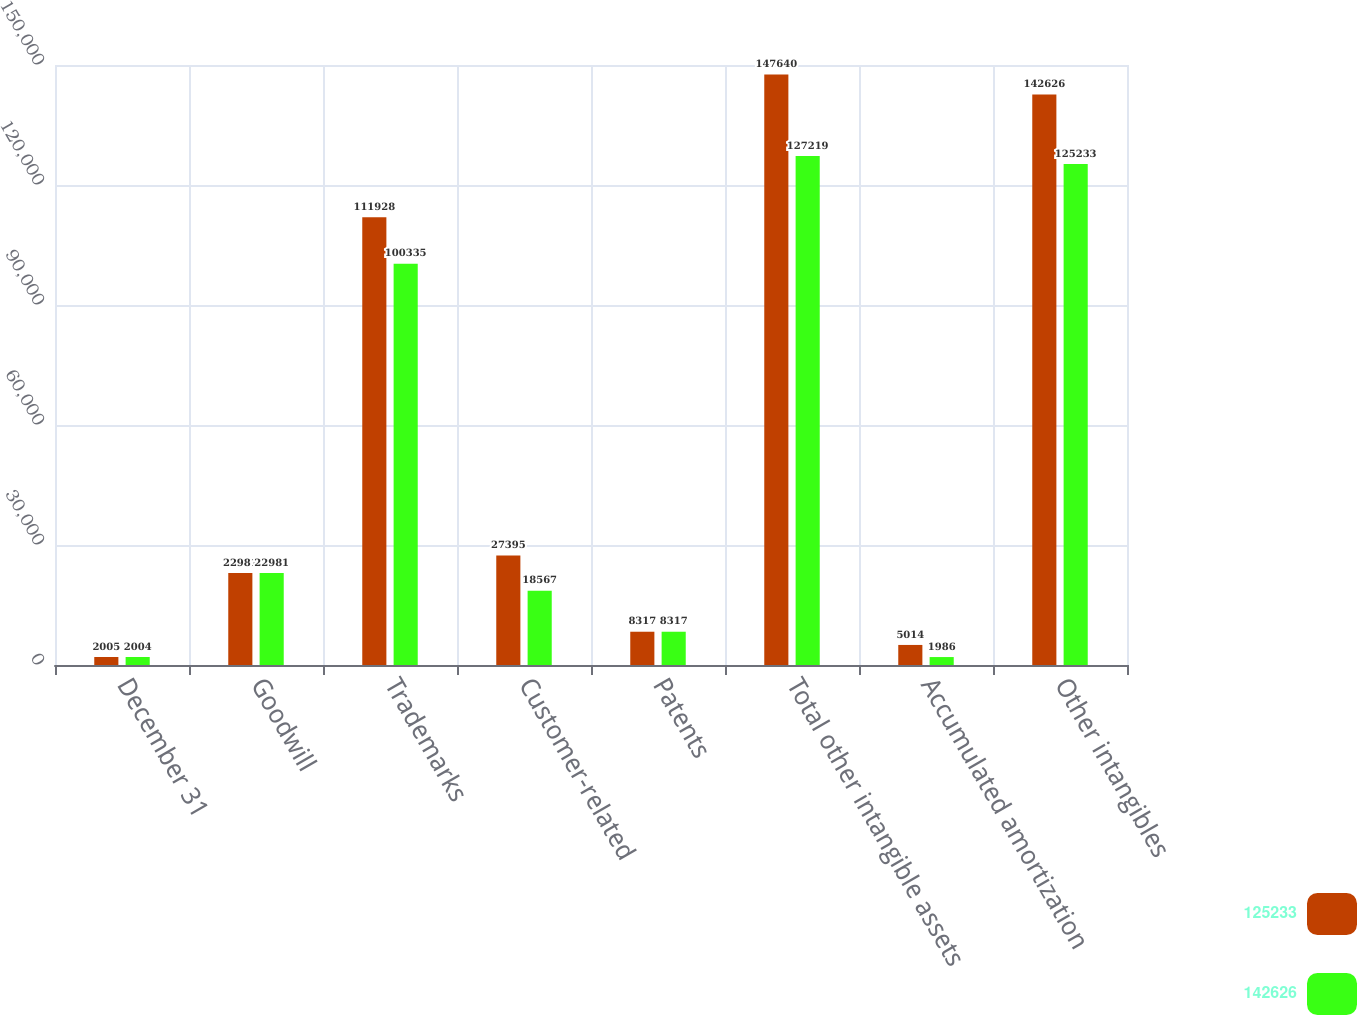Convert chart. <chart><loc_0><loc_0><loc_500><loc_500><stacked_bar_chart><ecel><fcel>December 31<fcel>Goodwill<fcel>Trademarks<fcel>Customer-related<fcel>Patents<fcel>Total other intangible assets<fcel>Accumulated amortization<fcel>Other intangibles<nl><fcel>125233<fcel>2005<fcel>22981<fcel>111928<fcel>27395<fcel>8317<fcel>147640<fcel>5014<fcel>142626<nl><fcel>142626<fcel>2004<fcel>22981<fcel>100335<fcel>18567<fcel>8317<fcel>127219<fcel>1986<fcel>125233<nl></chart> 